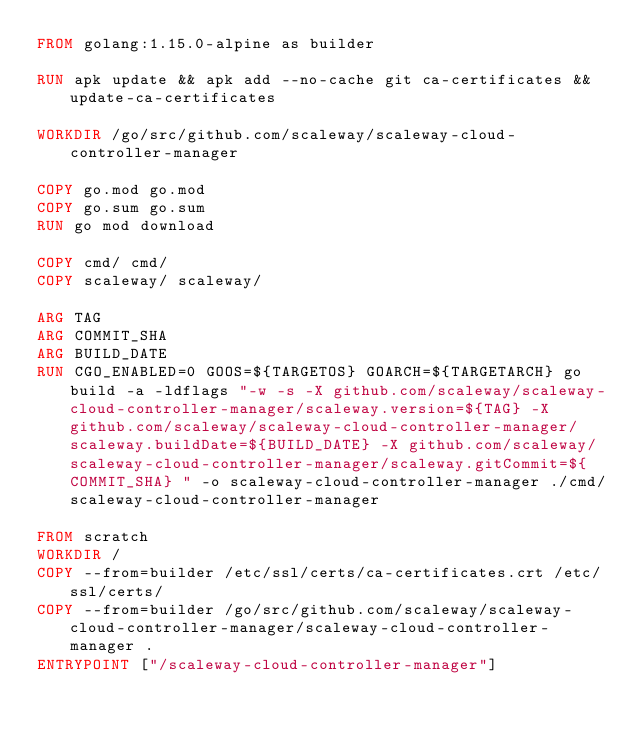Convert code to text. <code><loc_0><loc_0><loc_500><loc_500><_Dockerfile_>FROM golang:1.15.0-alpine as builder

RUN apk update && apk add --no-cache git ca-certificates && update-ca-certificates

WORKDIR /go/src/github.com/scaleway/scaleway-cloud-controller-manager

COPY go.mod go.mod
COPY go.sum go.sum
RUN go mod download

COPY cmd/ cmd/
COPY scaleway/ scaleway/

ARG TAG
ARG COMMIT_SHA
ARG BUILD_DATE
RUN CGO_ENABLED=0 GOOS=${TARGETOS} GOARCH=${TARGETARCH} go build -a -ldflags "-w -s -X github.com/scaleway/scaleway-cloud-controller-manager/scaleway.version=${TAG} -X github.com/scaleway/scaleway-cloud-controller-manager/scaleway.buildDate=${BUILD_DATE} -X github.com/scaleway/scaleway-cloud-controller-manager/scaleway.gitCommit=${COMMIT_SHA} " -o scaleway-cloud-controller-manager ./cmd/scaleway-cloud-controller-manager

FROM scratch
WORKDIR /
COPY --from=builder /etc/ssl/certs/ca-certificates.crt /etc/ssl/certs/
COPY --from=builder /go/src/github.com/scaleway/scaleway-cloud-controller-manager/scaleway-cloud-controller-manager .
ENTRYPOINT ["/scaleway-cloud-controller-manager"]
</code> 